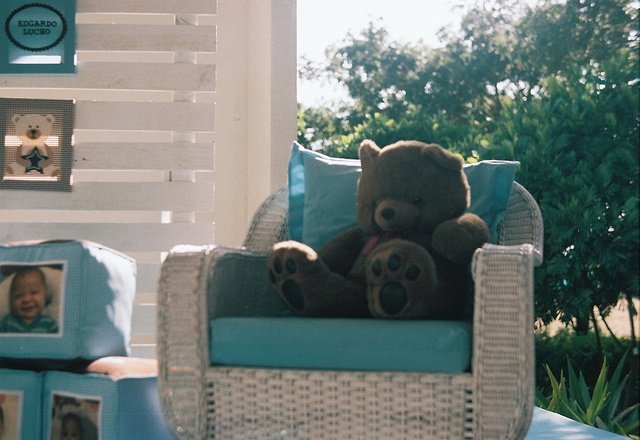Describe the objects in this image and their specific colors. I can see couch in teal and gray tones, chair in teal and gray tones, teddy bear in teal, black, and gray tones, chair in teal and black tones, and people in teal, black, and maroon tones in this image. 